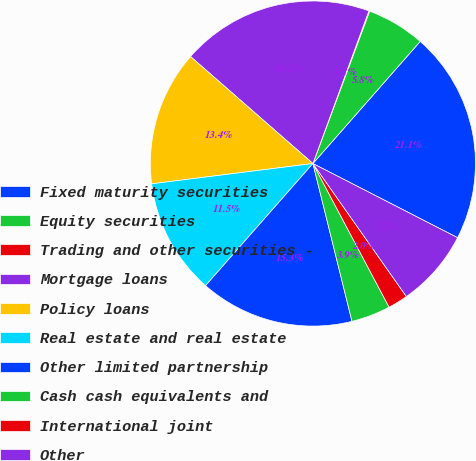<chart> <loc_0><loc_0><loc_500><loc_500><pie_chart><fcel>Fixed maturity securities<fcel>Equity securities<fcel>Trading and other securities -<fcel>Mortgage loans<fcel>Policy loans<fcel>Real estate and real estate<fcel>Other limited partnership<fcel>Cash cash equivalents and<fcel>International joint<fcel>Other<nl><fcel>21.07%<fcel>5.8%<fcel>0.08%<fcel>19.16%<fcel>13.43%<fcel>11.53%<fcel>15.34%<fcel>3.9%<fcel>1.99%<fcel>7.71%<nl></chart> 